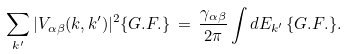Convert formula to latex. <formula><loc_0><loc_0><loc_500><loc_500>\sum _ { k ^ { \prime } } | V _ { \alpha \beta } ( { k } , { k ^ { \prime } } ) | ^ { 2 } \{ G . F . \} \, = \, \frac { \gamma _ { \alpha \beta } } { 2 \pi } \int d E _ { k ^ { \prime } } \, \{ G . F . \} .</formula> 